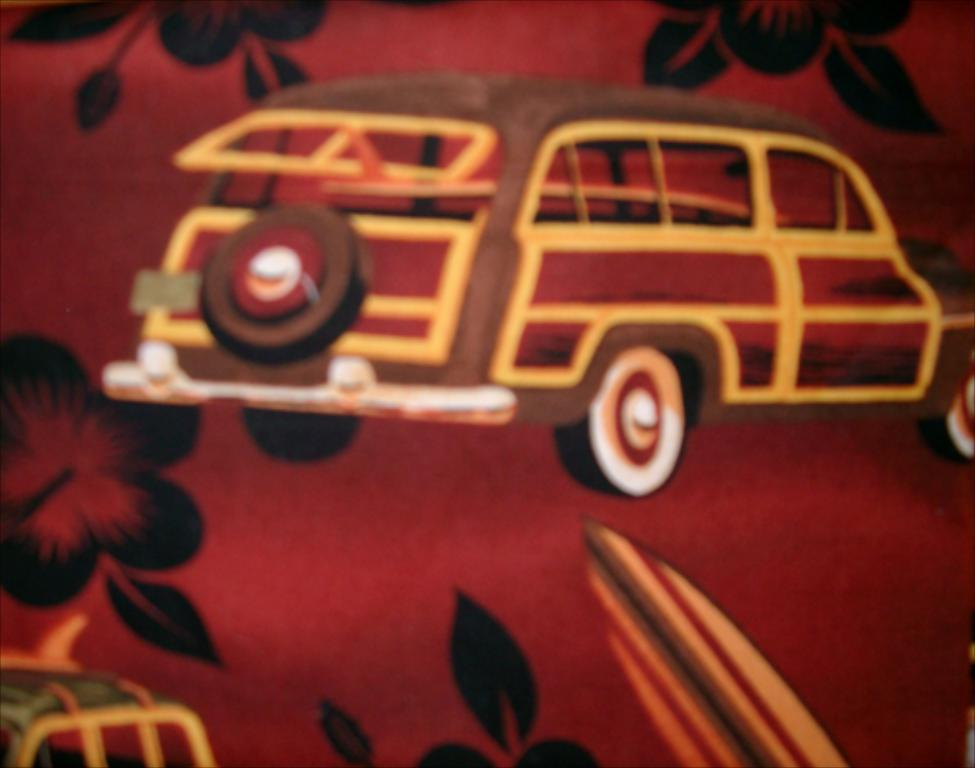What is the main subject of the image? The main subject of the image is a cloth. What types of images are depicted on the cloth? The cloth has pictures of vehicles and flowers. Can you see any snakes slithering through the field in the image? There is no field or snake present in the image; it features a cloth with pictures of vehicles and flowers. 